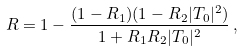<formula> <loc_0><loc_0><loc_500><loc_500>R = 1 - \frac { ( 1 - R _ { 1 } ) ( 1 - R _ { 2 } | T _ { 0 } | ^ { 2 } ) } { 1 + R _ { 1 } R _ { 2 } | T _ { 0 } | ^ { 2 } } \, ,</formula> 